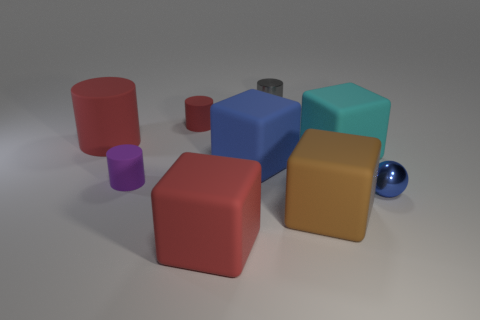There is a blue object on the left side of the cylinder that is to the right of the big red rubber block; how big is it?
Your answer should be very brief. Large. Does the cyan thing have the same size as the red matte block?
Give a very brief answer. Yes. Is there a shiny object in front of the cylinder that is to the right of the large matte thing that is in front of the brown matte thing?
Your answer should be very brief. Yes. The blue sphere has what size?
Ensure brevity in your answer.  Small. What number of brown objects have the same size as the cyan thing?
Make the answer very short. 1. What material is the tiny gray object that is the same shape as the purple rubber thing?
Provide a succinct answer. Metal. The object that is in front of the tiny purple matte object and on the right side of the large brown thing has what shape?
Keep it short and to the point. Sphere. There is a metal thing that is in front of the large blue rubber block; what shape is it?
Offer a very short reply. Sphere. What number of things are on the left side of the blue metal object and behind the large brown thing?
Offer a very short reply. 6. Do the cyan rubber thing and the red object in front of the cyan rubber object have the same size?
Provide a short and direct response. Yes. 